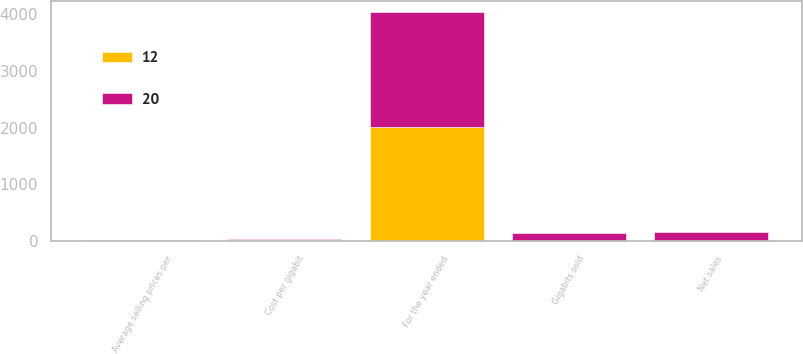Convert chart to OTSL. <chart><loc_0><loc_0><loc_500><loc_500><stacked_bar_chart><ecel><fcel>For the year ended<fcel>Net sales<fcel>Average selling prices per<fcel>Gigabits sold<fcel>Cost per gigabit<nl><fcel>12<fcel>2015<fcel>7<fcel>11<fcel>4<fcel>12<nl><fcel>20<fcel>2014<fcel>156<fcel>6<fcel>142<fcel>20<nl></chart> 